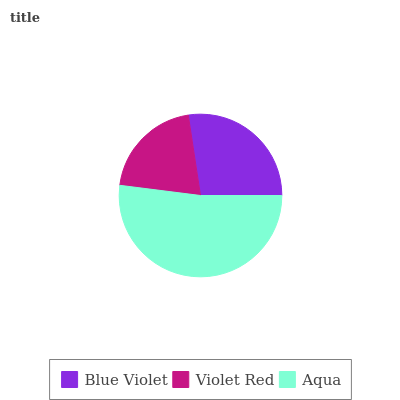Is Violet Red the minimum?
Answer yes or no. Yes. Is Aqua the maximum?
Answer yes or no. Yes. Is Aqua the minimum?
Answer yes or no. No. Is Violet Red the maximum?
Answer yes or no. No. Is Aqua greater than Violet Red?
Answer yes or no. Yes. Is Violet Red less than Aqua?
Answer yes or no. Yes. Is Violet Red greater than Aqua?
Answer yes or no. No. Is Aqua less than Violet Red?
Answer yes or no. No. Is Blue Violet the high median?
Answer yes or no. Yes. Is Blue Violet the low median?
Answer yes or no. Yes. Is Violet Red the high median?
Answer yes or no. No. Is Aqua the low median?
Answer yes or no. No. 